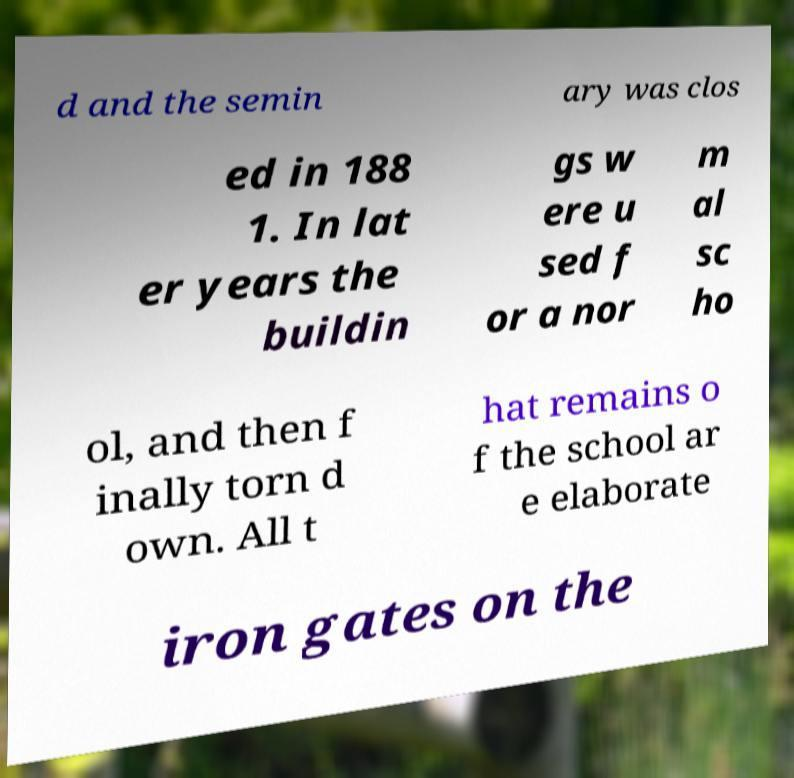Can you read and provide the text displayed in the image?This photo seems to have some interesting text. Can you extract and type it out for me? d and the semin ary was clos ed in 188 1. In lat er years the buildin gs w ere u sed f or a nor m al sc ho ol, and then f inally torn d own. All t hat remains o f the school ar e elaborate iron gates on the 